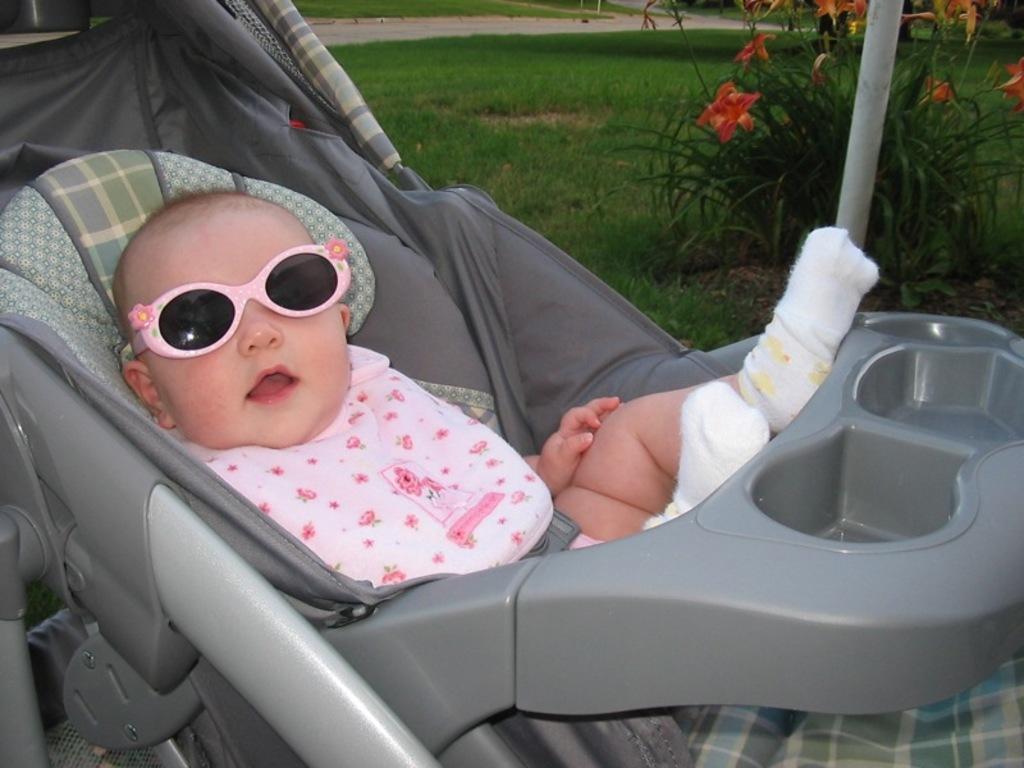Please provide a concise description of this image. This image consists of a stroller. In that there is a baby. She is wearing goggles and socks. There is a plant in the top right corner. 